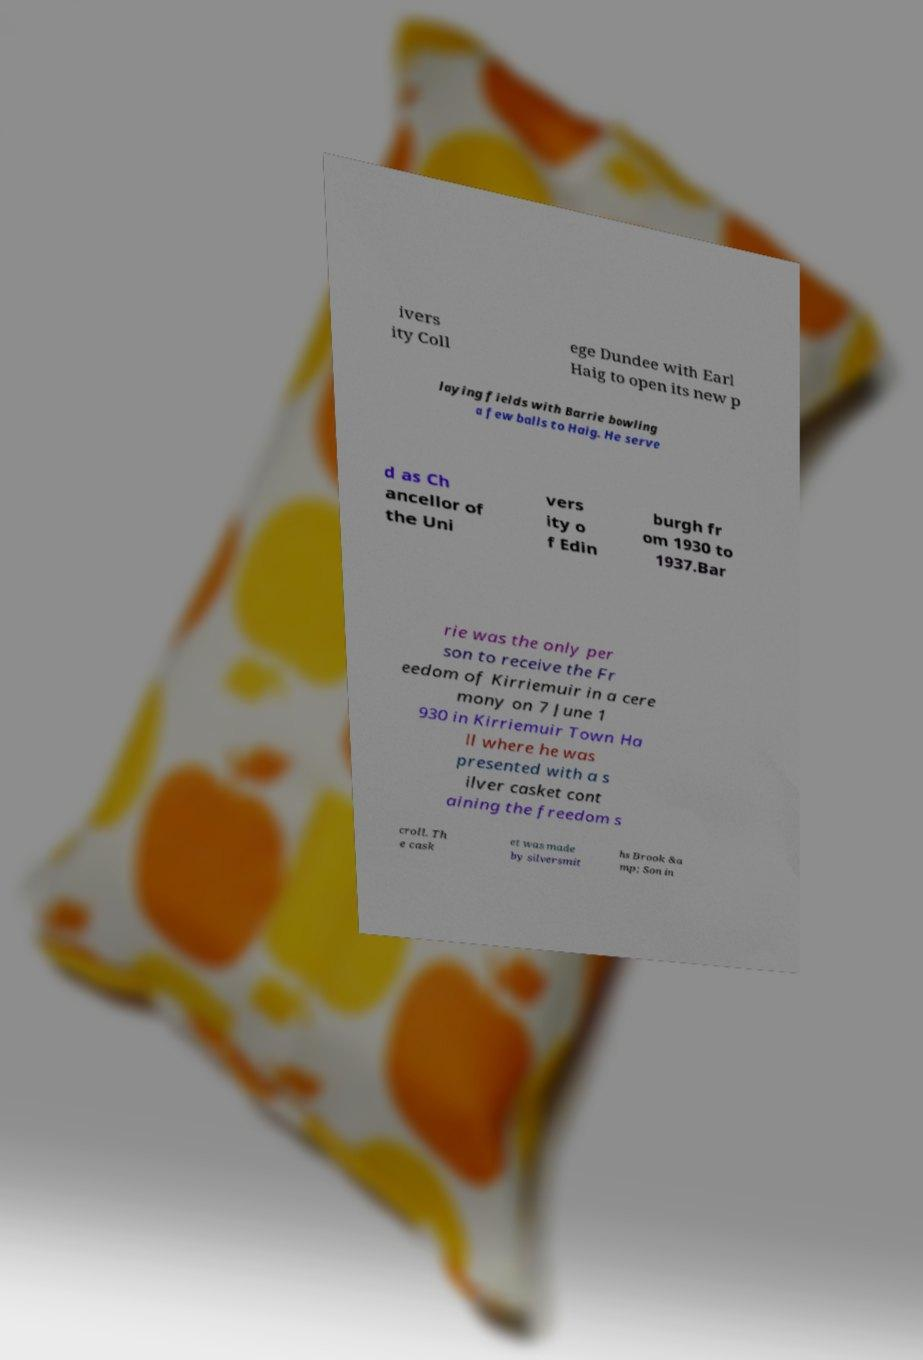Please read and relay the text visible in this image. What does it say? ivers ity Coll ege Dundee with Earl Haig to open its new p laying fields with Barrie bowling a few balls to Haig. He serve d as Ch ancellor of the Uni vers ity o f Edin burgh fr om 1930 to 1937.Bar rie was the only per son to receive the Fr eedom of Kirriemuir in a cere mony on 7 June 1 930 in Kirriemuir Town Ha ll where he was presented with a s ilver casket cont aining the freedom s croll. Th e cask et was made by silversmit hs Brook &a mp; Son in 